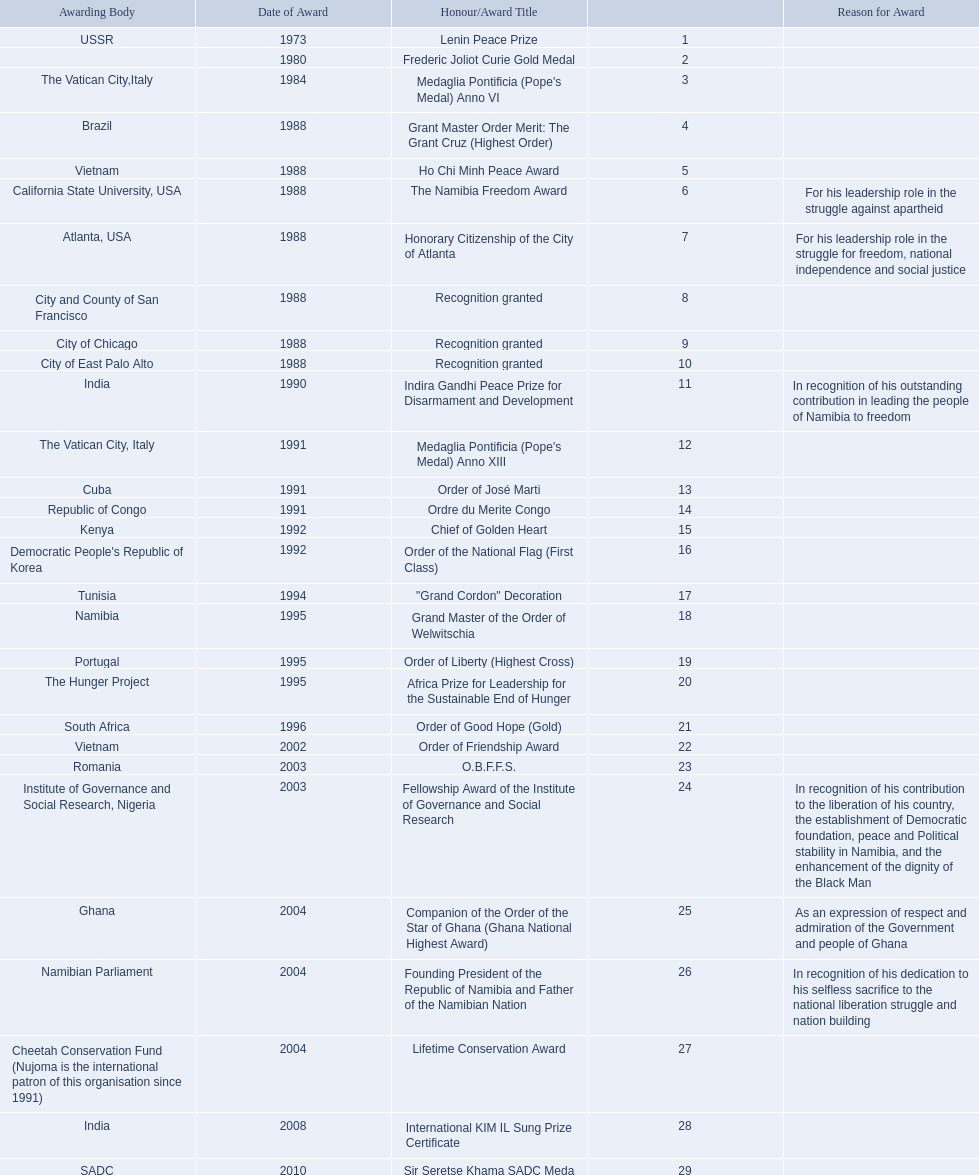What awards did sam nujoma win? 1, 1973, Lenin Peace Prize, Frederic Joliot Curie Gold Medal, Medaglia Pontificia (Pope's Medal) Anno VI, Grant Master Order Merit: The Grant Cruz (Highest Order), Ho Chi Minh Peace Award, The Namibia Freedom Award, Honorary Citizenship of the City of Atlanta, Recognition granted, Recognition granted, Recognition granted, Indira Gandhi Peace Prize for Disarmament and Development, Medaglia Pontificia (Pope's Medal) Anno XIII, Order of José Marti, Ordre du Merite Congo, Chief of Golden Heart, Order of the National Flag (First Class), "Grand Cordon" Decoration, Grand Master of the Order of Welwitschia, Order of Liberty (Highest Cross), Africa Prize for Leadership for the Sustainable End of Hunger, Order of Good Hope (Gold), Order of Friendship Award, O.B.F.F.S., Fellowship Award of the Institute of Governance and Social Research, Companion of the Order of the Star of Ghana (Ghana National Highest Award), Founding President of the Republic of Namibia and Father of the Namibian Nation, Lifetime Conservation Award, International KIM IL Sung Prize Certificate, Sir Seretse Khama SADC Meda. Who was the awarding body for the o.b.f.f.s award? Romania. 